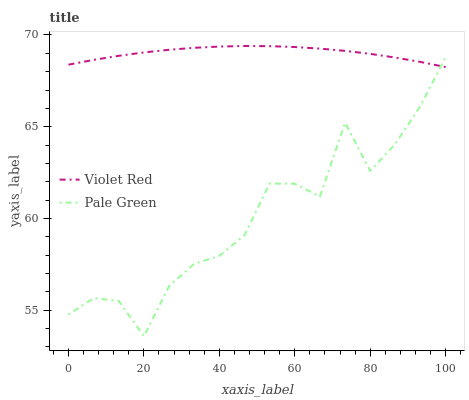Does Pale Green have the minimum area under the curve?
Answer yes or no. Yes. Does Violet Red have the maximum area under the curve?
Answer yes or no. Yes. Does Pale Green have the maximum area under the curve?
Answer yes or no. No. Is Violet Red the smoothest?
Answer yes or no. Yes. Is Pale Green the roughest?
Answer yes or no. Yes. Is Pale Green the smoothest?
Answer yes or no. No. Does Violet Red have the highest value?
Answer yes or no. Yes. Does Pale Green have the highest value?
Answer yes or no. No. Does Violet Red intersect Pale Green?
Answer yes or no. Yes. Is Violet Red less than Pale Green?
Answer yes or no. No. Is Violet Red greater than Pale Green?
Answer yes or no. No. 